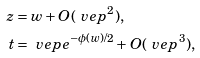<formula> <loc_0><loc_0><loc_500><loc_500>z & = w + O ( \ v e p ^ { 2 } ) , \\ t & = \ v e p e ^ { - \phi ( w ) / 2 } + O ( \ v e p ^ { 3 } ) ,</formula> 